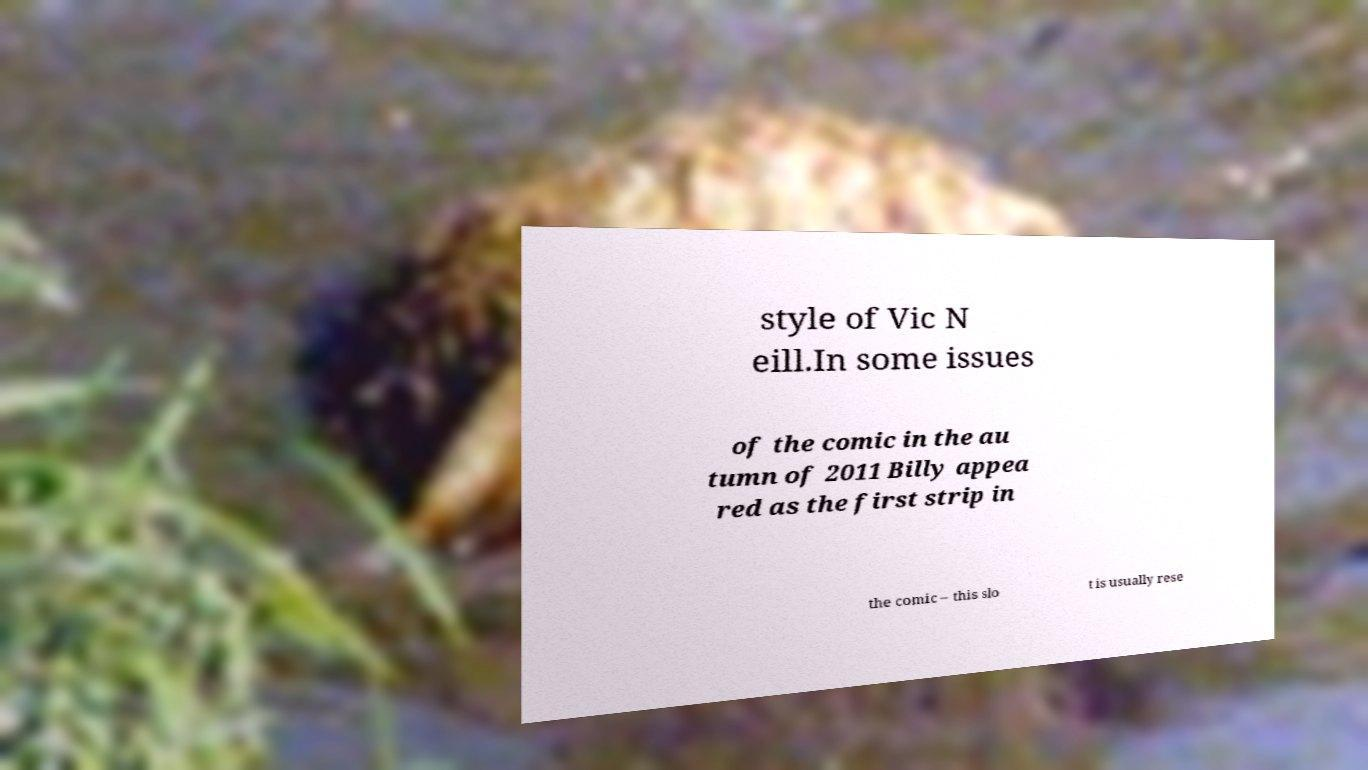For documentation purposes, I need the text within this image transcribed. Could you provide that? style of Vic N eill.In some issues of the comic in the au tumn of 2011 Billy appea red as the first strip in the comic – this slo t is usually rese 